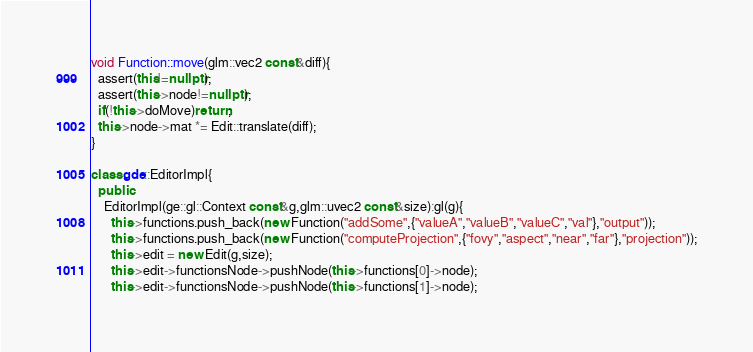Convert code to text. <code><loc_0><loc_0><loc_500><loc_500><_C++_>
void Function::move(glm::vec2 const&diff){
  assert(this!=nullptr);
  assert(this->node!=nullptr);
  if(!this->doMove)return;
  this->node->mat *= Edit::translate(diff); 
}

class gde::EditorImpl{
  public:
    EditorImpl(ge::gl::Context const&g,glm::uvec2 const&size):gl(g){
      this->functions.push_back(new Function("addSome",{"valueA","valueB","valueC","val"},"output"));
      this->functions.push_back(new Function("computeProjection",{"fovy","aspect","near","far"},"projection"));
      this->edit = new Edit(g,size);
      this->edit->functionsNode->pushNode(this->functions[0]->node);
      this->edit->functionsNode->pushNode(this->functions[1]->node);</code> 